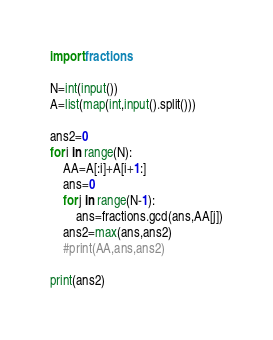Convert code to text. <code><loc_0><loc_0><loc_500><loc_500><_Python_>import fractions

N=int(input())
A=list(map(int,input().split()))

ans2=0
for i in range(N):
    AA=A[:i]+A[i+1:]
    ans=0
    for j in range(N-1):
        ans=fractions.gcd(ans,AA[j])
    ans2=max(ans,ans2)
    #print(AA,ans,ans2)

print(ans2)</code> 